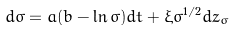Convert formula to latex. <formula><loc_0><loc_0><loc_500><loc_500>d \sigma = a ( b - \ln \sigma ) d t + \xi \sigma ^ { 1 / 2 } d z _ { \sigma }</formula> 